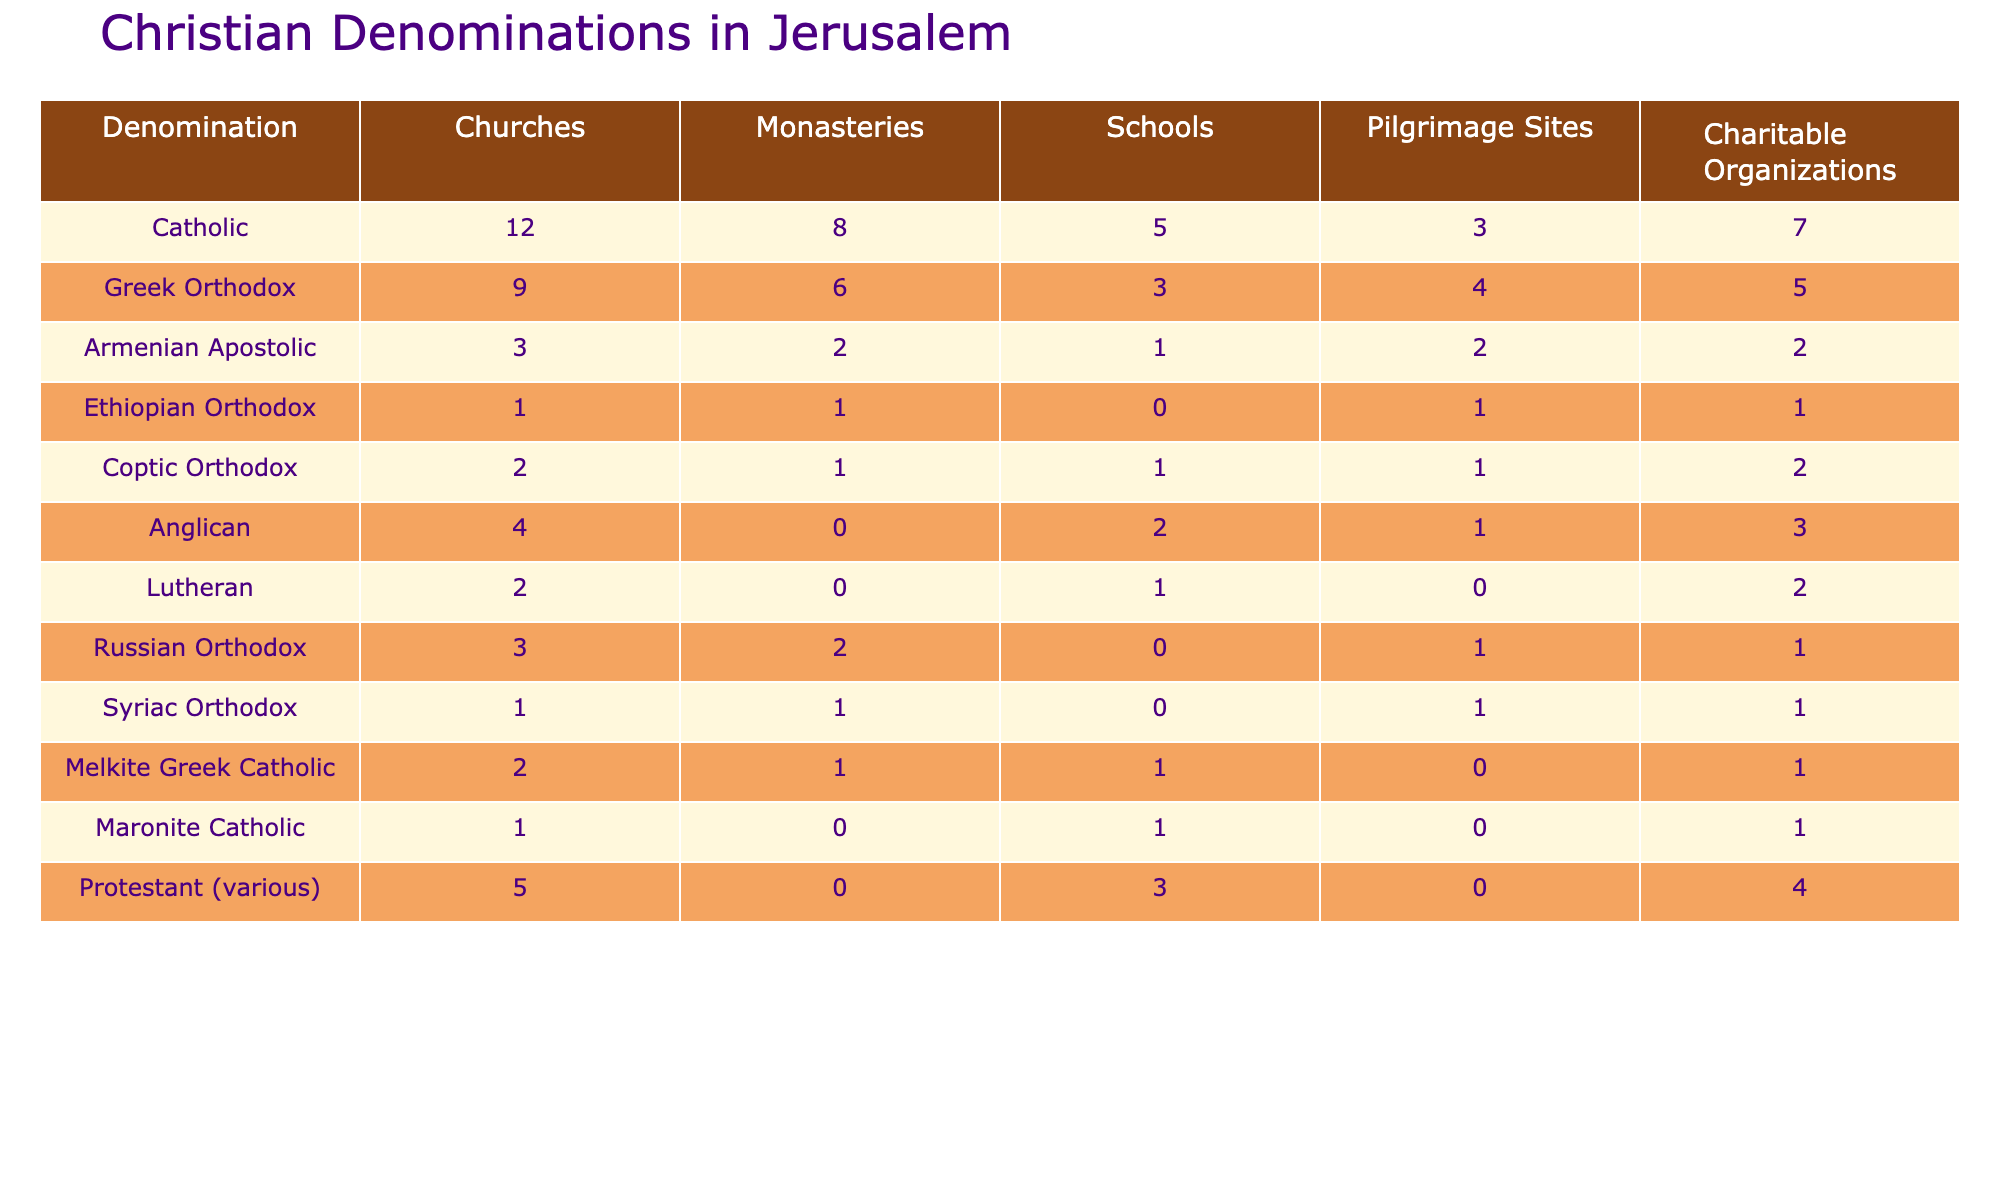What denomination has the most churches in Jerusalem? The table shows that the Catholic denomination has 12 churches, which is the highest count compared to others.
Answer: Catholic How many charitable organizations does the Armenian Apostolic church have? Referring to the table, the Armenian Apostolic church has 2 charitable organizations.
Answer: 2 Which denomination has the least number of schools? According to the table, the Ethiopian Orthodox denomination has 0 schools, making it the least.
Answer: Ethiopian Orthodox What is the total number of pilgrimage sites across all denominations? To find the total, sum the pilgrimage sites: (3 + 4 + 2 + 1 + 1 + 1 + 0 + 1 + 0 + 0 + 1 + 0 + 0) = 14.
Answer: 14 For which denomination is the number of monasteries equal to the number of charitable organizations? The Syrian Orthodox and Ethiopian Orthodox both have 1 monastery and 1 charitable organization, so the answer is both.
Answer: Syriac Orthodox, Ethiopian Orthodox What's the difference in the number of schools between the Greek Orthodox and the Anglican denominations? Greek Orthodox has 3 schools and Anglican has 2 schools. The difference is 3 - 2 = 1.
Answer: 1 Which denomination has more monasteries than schools? The Catholic, Greek Orthodox, Armenian Apostolic, and Russian Orthodox denominations all have more monasteries than schools (8, 6, 2, and 2 respectively, compared to their schools' 5, 3, 1, and 0).
Answer: Catholic, Greek Orthodox, Armenian Apostolic, Russian Orthodox What is the average number of churches among all denominations? To calculate the average, sum the number of churches (12 + 9 + 3 + 1 + 2 + 4 + 2 + 3 + 1 + 2 + 1 + 5) = 43, then divide by the number of denominations (12): 43 / 12 = approximately 3.58.
Answer: 3.58 Is there a Christian denomination that has no monasteries or schools? According to the table, the Anglican and Lutheran denominations both have 0 monasteries and 1 school each (0 for monasteries). Therefore, the claim is true for Lutheran and Anglican as they do not have monasteries.
Answer: Yes What is the highest total of churches, monasteries, schools, pilgrimage sites, and charitable organizations for any single denomination? To find the highest total: Catholic (12+8+5+3+7 = 35), Greek Orthodox (9+6+3+4+5 = 27), Armenian Apostolic (3+2+1+2+2 = 10), and so on. The Catholic denomination has the highest total, which is 35.
Answer: 35 